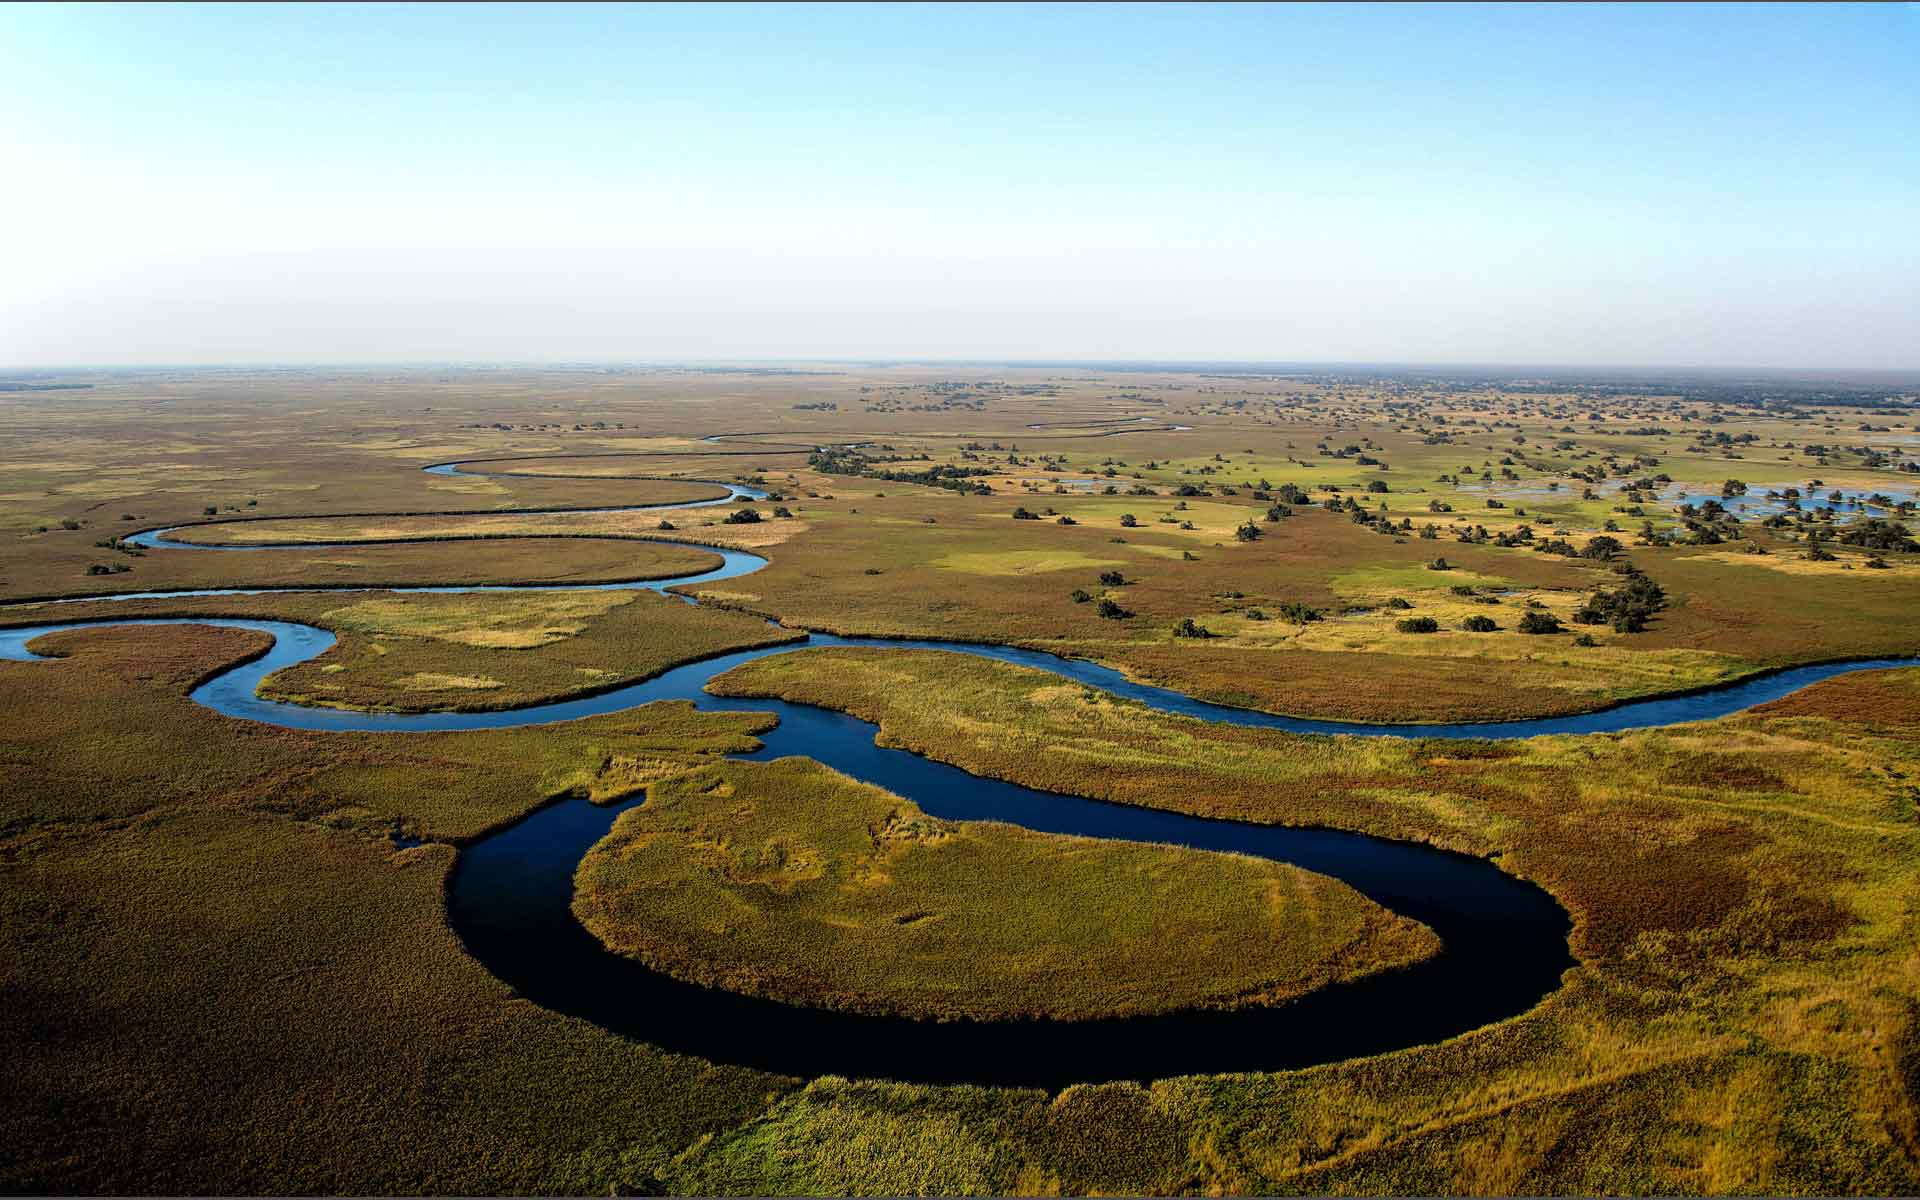Can you explain why the water paths in the Okavango Delta are so sinuous and not straight? The sinuous or meandering paths of the waterways in the Okavango Delta are primarily due to the flat landscape and the soft, easily erodible soil found throughout the area. Over time, the flow of water naturally seeks the path of least resistance, gradually eroding the riverbanks and forming curvaceous paths. These winding routes are also influenced by obstacles like vegetation growth, sediment accumulation, and the dynamic seasonal flooding patterns that reshape the channels annually. 